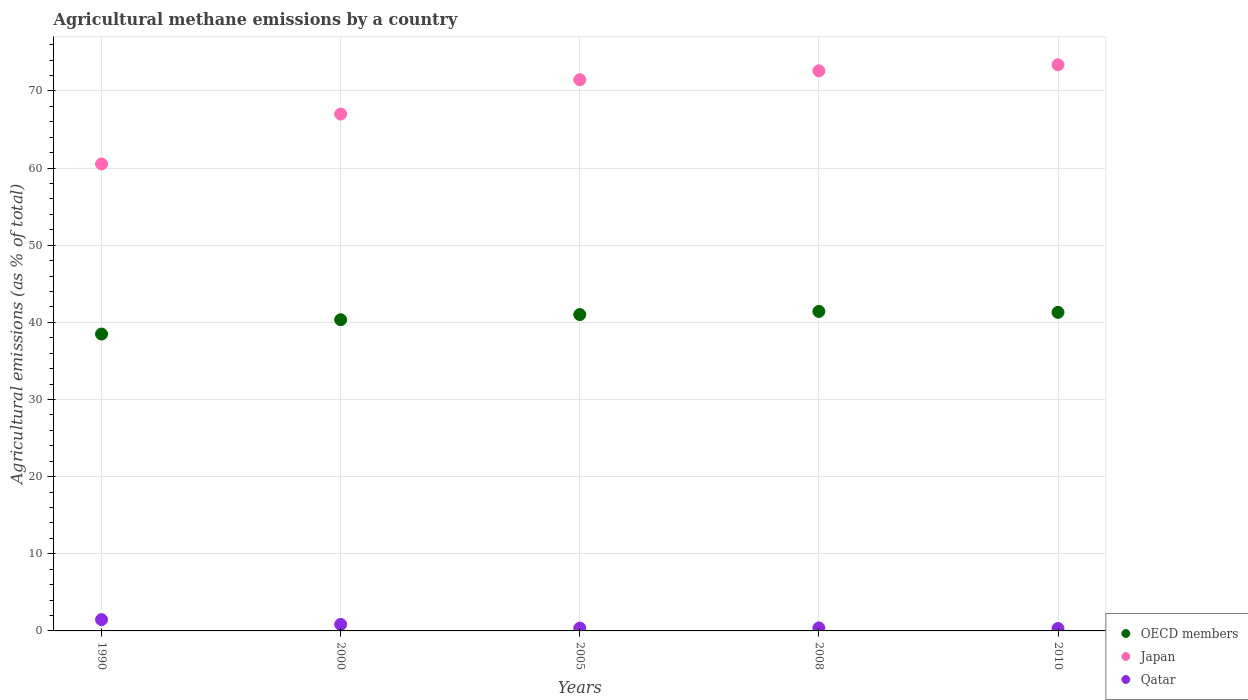What is the amount of agricultural methane emitted in Qatar in 2010?
Keep it short and to the point. 0.31. Across all years, what is the maximum amount of agricultural methane emitted in OECD members?
Offer a very short reply. 41.41. Across all years, what is the minimum amount of agricultural methane emitted in Qatar?
Give a very brief answer. 0.31. In which year was the amount of agricultural methane emitted in OECD members minimum?
Ensure brevity in your answer.  1990. What is the total amount of agricultural methane emitted in Qatar in the graph?
Your answer should be very brief. 3.38. What is the difference between the amount of agricultural methane emitted in OECD members in 2005 and that in 2008?
Make the answer very short. -0.41. What is the difference between the amount of agricultural methane emitted in Japan in 2000 and the amount of agricultural methane emitted in OECD members in 2005?
Give a very brief answer. 25.99. What is the average amount of agricultural methane emitted in Japan per year?
Offer a terse response. 68.99. In the year 2000, what is the difference between the amount of agricultural methane emitted in Qatar and amount of agricultural methane emitted in OECD members?
Your answer should be compact. -39.49. In how many years, is the amount of agricultural methane emitted in Japan greater than 60 %?
Ensure brevity in your answer.  5. What is the ratio of the amount of agricultural methane emitted in Japan in 1990 to that in 2005?
Offer a very short reply. 0.85. Is the amount of agricultural methane emitted in Japan in 1990 less than that in 2000?
Make the answer very short. Yes. What is the difference between the highest and the second highest amount of agricultural methane emitted in OECD members?
Offer a terse response. 0.12. What is the difference between the highest and the lowest amount of agricultural methane emitted in Qatar?
Ensure brevity in your answer.  1.15. In how many years, is the amount of agricultural methane emitted in Qatar greater than the average amount of agricultural methane emitted in Qatar taken over all years?
Offer a terse response. 2. Is the sum of the amount of agricultural methane emitted in OECD members in 2000 and 2005 greater than the maximum amount of agricultural methane emitted in Japan across all years?
Keep it short and to the point. Yes. Does the amount of agricultural methane emitted in Qatar monotonically increase over the years?
Your answer should be compact. No. Is the amount of agricultural methane emitted in Japan strictly greater than the amount of agricultural methane emitted in Qatar over the years?
Your answer should be very brief. Yes. How many years are there in the graph?
Give a very brief answer. 5. Does the graph contain any zero values?
Ensure brevity in your answer.  No. Does the graph contain grids?
Offer a terse response. Yes. What is the title of the graph?
Ensure brevity in your answer.  Agricultural methane emissions by a country. What is the label or title of the X-axis?
Your response must be concise. Years. What is the label or title of the Y-axis?
Offer a very short reply. Agricultural emissions (as % of total). What is the Agricultural emissions (as % of total) of OECD members in 1990?
Your response must be concise. 38.48. What is the Agricultural emissions (as % of total) of Japan in 1990?
Make the answer very short. 60.53. What is the Agricultural emissions (as % of total) in Qatar in 1990?
Your answer should be compact. 1.46. What is the Agricultural emissions (as % of total) in OECD members in 2000?
Provide a succinct answer. 40.33. What is the Agricultural emissions (as % of total) in Japan in 2000?
Your response must be concise. 66.99. What is the Agricultural emissions (as % of total) in Qatar in 2000?
Keep it short and to the point. 0.85. What is the Agricultural emissions (as % of total) in OECD members in 2005?
Provide a short and direct response. 41. What is the Agricultural emissions (as % of total) in Japan in 2005?
Offer a terse response. 71.44. What is the Agricultural emissions (as % of total) in Qatar in 2005?
Your answer should be compact. 0.36. What is the Agricultural emissions (as % of total) in OECD members in 2008?
Provide a succinct answer. 41.41. What is the Agricultural emissions (as % of total) in Japan in 2008?
Offer a terse response. 72.6. What is the Agricultural emissions (as % of total) in Qatar in 2008?
Provide a succinct answer. 0.39. What is the Agricultural emissions (as % of total) of OECD members in 2010?
Keep it short and to the point. 41.29. What is the Agricultural emissions (as % of total) in Japan in 2010?
Offer a terse response. 73.38. What is the Agricultural emissions (as % of total) of Qatar in 2010?
Your answer should be compact. 0.31. Across all years, what is the maximum Agricultural emissions (as % of total) in OECD members?
Your response must be concise. 41.41. Across all years, what is the maximum Agricultural emissions (as % of total) of Japan?
Keep it short and to the point. 73.38. Across all years, what is the maximum Agricultural emissions (as % of total) in Qatar?
Make the answer very short. 1.46. Across all years, what is the minimum Agricultural emissions (as % of total) in OECD members?
Keep it short and to the point. 38.48. Across all years, what is the minimum Agricultural emissions (as % of total) in Japan?
Provide a short and direct response. 60.53. Across all years, what is the minimum Agricultural emissions (as % of total) in Qatar?
Your answer should be compact. 0.31. What is the total Agricultural emissions (as % of total) in OECD members in the graph?
Make the answer very short. 202.52. What is the total Agricultural emissions (as % of total) in Japan in the graph?
Offer a terse response. 344.94. What is the total Agricultural emissions (as % of total) of Qatar in the graph?
Give a very brief answer. 3.38. What is the difference between the Agricultural emissions (as % of total) in OECD members in 1990 and that in 2000?
Provide a succinct answer. -1.86. What is the difference between the Agricultural emissions (as % of total) of Japan in 1990 and that in 2000?
Your response must be concise. -6.46. What is the difference between the Agricultural emissions (as % of total) in Qatar in 1990 and that in 2000?
Make the answer very short. 0.61. What is the difference between the Agricultural emissions (as % of total) of OECD members in 1990 and that in 2005?
Your answer should be very brief. -2.52. What is the difference between the Agricultural emissions (as % of total) in Japan in 1990 and that in 2005?
Keep it short and to the point. -10.92. What is the difference between the Agricultural emissions (as % of total) in Qatar in 1990 and that in 2005?
Your response must be concise. 1.1. What is the difference between the Agricultural emissions (as % of total) in OECD members in 1990 and that in 2008?
Your answer should be very brief. -2.93. What is the difference between the Agricultural emissions (as % of total) of Japan in 1990 and that in 2008?
Your answer should be very brief. -12.07. What is the difference between the Agricultural emissions (as % of total) in Qatar in 1990 and that in 2008?
Give a very brief answer. 1.07. What is the difference between the Agricultural emissions (as % of total) in OECD members in 1990 and that in 2010?
Ensure brevity in your answer.  -2.81. What is the difference between the Agricultural emissions (as % of total) in Japan in 1990 and that in 2010?
Offer a terse response. -12.86. What is the difference between the Agricultural emissions (as % of total) in Qatar in 1990 and that in 2010?
Your answer should be compact. 1.15. What is the difference between the Agricultural emissions (as % of total) of OECD members in 2000 and that in 2005?
Give a very brief answer. -0.67. What is the difference between the Agricultural emissions (as % of total) of Japan in 2000 and that in 2005?
Ensure brevity in your answer.  -4.46. What is the difference between the Agricultural emissions (as % of total) of Qatar in 2000 and that in 2005?
Make the answer very short. 0.49. What is the difference between the Agricultural emissions (as % of total) of OECD members in 2000 and that in 2008?
Make the answer very short. -1.08. What is the difference between the Agricultural emissions (as % of total) of Japan in 2000 and that in 2008?
Your answer should be very brief. -5.61. What is the difference between the Agricultural emissions (as % of total) in Qatar in 2000 and that in 2008?
Make the answer very short. 0.46. What is the difference between the Agricultural emissions (as % of total) in OECD members in 2000 and that in 2010?
Make the answer very short. -0.96. What is the difference between the Agricultural emissions (as % of total) of Japan in 2000 and that in 2010?
Your answer should be very brief. -6.39. What is the difference between the Agricultural emissions (as % of total) in Qatar in 2000 and that in 2010?
Keep it short and to the point. 0.54. What is the difference between the Agricultural emissions (as % of total) in OECD members in 2005 and that in 2008?
Your answer should be very brief. -0.41. What is the difference between the Agricultural emissions (as % of total) in Japan in 2005 and that in 2008?
Give a very brief answer. -1.15. What is the difference between the Agricultural emissions (as % of total) in Qatar in 2005 and that in 2008?
Offer a very short reply. -0.03. What is the difference between the Agricultural emissions (as % of total) of OECD members in 2005 and that in 2010?
Ensure brevity in your answer.  -0.29. What is the difference between the Agricultural emissions (as % of total) of Japan in 2005 and that in 2010?
Your response must be concise. -1.94. What is the difference between the Agricultural emissions (as % of total) of Qatar in 2005 and that in 2010?
Keep it short and to the point. 0.05. What is the difference between the Agricultural emissions (as % of total) of OECD members in 2008 and that in 2010?
Keep it short and to the point. 0.12. What is the difference between the Agricultural emissions (as % of total) in Japan in 2008 and that in 2010?
Offer a terse response. -0.79. What is the difference between the Agricultural emissions (as % of total) in Qatar in 2008 and that in 2010?
Your answer should be compact. 0.08. What is the difference between the Agricultural emissions (as % of total) in OECD members in 1990 and the Agricultural emissions (as % of total) in Japan in 2000?
Your answer should be very brief. -28.51. What is the difference between the Agricultural emissions (as % of total) in OECD members in 1990 and the Agricultural emissions (as % of total) in Qatar in 2000?
Ensure brevity in your answer.  37.63. What is the difference between the Agricultural emissions (as % of total) of Japan in 1990 and the Agricultural emissions (as % of total) of Qatar in 2000?
Offer a terse response. 59.68. What is the difference between the Agricultural emissions (as % of total) of OECD members in 1990 and the Agricultural emissions (as % of total) of Japan in 2005?
Give a very brief answer. -32.97. What is the difference between the Agricultural emissions (as % of total) of OECD members in 1990 and the Agricultural emissions (as % of total) of Qatar in 2005?
Provide a succinct answer. 38.12. What is the difference between the Agricultural emissions (as % of total) of Japan in 1990 and the Agricultural emissions (as % of total) of Qatar in 2005?
Provide a succinct answer. 60.16. What is the difference between the Agricultural emissions (as % of total) in OECD members in 1990 and the Agricultural emissions (as % of total) in Japan in 2008?
Your response must be concise. -34.12. What is the difference between the Agricultural emissions (as % of total) of OECD members in 1990 and the Agricultural emissions (as % of total) of Qatar in 2008?
Your answer should be very brief. 38.09. What is the difference between the Agricultural emissions (as % of total) in Japan in 1990 and the Agricultural emissions (as % of total) in Qatar in 2008?
Offer a terse response. 60.14. What is the difference between the Agricultural emissions (as % of total) of OECD members in 1990 and the Agricultural emissions (as % of total) of Japan in 2010?
Give a very brief answer. -34.9. What is the difference between the Agricultural emissions (as % of total) in OECD members in 1990 and the Agricultural emissions (as % of total) in Qatar in 2010?
Give a very brief answer. 38.17. What is the difference between the Agricultural emissions (as % of total) in Japan in 1990 and the Agricultural emissions (as % of total) in Qatar in 2010?
Keep it short and to the point. 60.22. What is the difference between the Agricultural emissions (as % of total) of OECD members in 2000 and the Agricultural emissions (as % of total) of Japan in 2005?
Provide a succinct answer. -31.11. What is the difference between the Agricultural emissions (as % of total) in OECD members in 2000 and the Agricultural emissions (as % of total) in Qatar in 2005?
Your answer should be compact. 39.97. What is the difference between the Agricultural emissions (as % of total) in Japan in 2000 and the Agricultural emissions (as % of total) in Qatar in 2005?
Offer a very short reply. 66.63. What is the difference between the Agricultural emissions (as % of total) in OECD members in 2000 and the Agricultural emissions (as % of total) in Japan in 2008?
Provide a short and direct response. -32.26. What is the difference between the Agricultural emissions (as % of total) of OECD members in 2000 and the Agricultural emissions (as % of total) of Qatar in 2008?
Your response must be concise. 39.95. What is the difference between the Agricultural emissions (as % of total) in Japan in 2000 and the Agricultural emissions (as % of total) in Qatar in 2008?
Offer a terse response. 66.6. What is the difference between the Agricultural emissions (as % of total) of OECD members in 2000 and the Agricultural emissions (as % of total) of Japan in 2010?
Ensure brevity in your answer.  -33.05. What is the difference between the Agricultural emissions (as % of total) in OECD members in 2000 and the Agricultural emissions (as % of total) in Qatar in 2010?
Provide a succinct answer. 40.02. What is the difference between the Agricultural emissions (as % of total) in Japan in 2000 and the Agricultural emissions (as % of total) in Qatar in 2010?
Give a very brief answer. 66.68. What is the difference between the Agricultural emissions (as % of total) in OECD members in 2005 and the Agricultural emissions (as % of total) in Japan in 2008?
Your response must be concise. -31.59. What is the difference between the Agricultural emissions (as % of total) of OECD members in 2005 and the Agricultural emissions (as % of total) of Qatar in 2008?
Make the answer very short. 40.61. What is the difference between the Agricultural emissions (as % of total) in Japan in 2005 and the Agricultural emissions (as % of total) in Qatar in 2008?
Provide a succinct answer. 71.05. What is the difference between the Agricultural emissions (as % of total) in OECD members in 2005 and the Agricultural emissions (as % of total) in Japan in 2010?
Provide a short and direct response. -32.38. What is the difference between the Agricultural emissions (as % of total) in OECD members in 2005 and the Agricultural emissions (as % of total) in Qatar in 2010?
Provide a short and direct response. 40.69. What is the difference between the Agricultural emissions (as % of total) of Japan in 2005 and the Agricultural emissions (as % of total) of Qatar in 2010?
Make the answer very short. 71.13. What is the difference between the Agricultural emissions (as % of total) of OECD members in 2008 and the Agricultural emissions (as % of total) of Japan in 2010?
Make the answer very short. -31.97. What is the difference between the Agricultural emissions (as % of total) of OECD members in 2008 and the Agricultural emissions (as % of total) of Qatar in 2010?
Offer a very short reply. 41.1. What is the difference between the Agricultural emissions (as % of total) of Japan in 2008 and the Agricultural emissions (as % of total) of Qatar in 2010?
Provide a succinct answer. 72.28. What is the average Agricultural emissions (as % of total) of OECD members per year?
Your answer should be very brief. 40.5. What is the average Agricultural emissions (as % of total) in Japan per year?
Make the answer very short. 68.99. What is the average Agricultural emissions (as % of total) in Qatar per year?
Your answer should be very brief. 0.68. In the year 1990, what is the difference between the Agricultural emissions (as % of total) in OECD members and Agricultural emissions (as % of total) in Japan?
Ensure brevity in your answer.  -22.05. In the year 1990, what is the difference between the Agricultural emissions (as % of total) of OECD members and Agricultural emissions (as % of total) of Qatar?
Offer a terse response. 37.02. In the year 1990, what is the difference between the Agricultural emissions (as % of total) of Japan and Agricultural emissions (as % of total) of Qatar?
Make the answer very short. 59.06. In the year 2000, what is the difference between the Agricultural emissions (as % of total) in OECD members and Agricultural emissions (as % of total) in Japan?
Offer a very short reply. -26.65. In the year 2000, what is the difference between the Agricultural emissions (as % of total) in OECD members and Agricultural emissions (as % of total) in Qatar?
Make the answer very short. 39.49. In the year 2000, what is the difference between the Agricultural emissions (as % of total) of Japan and Agricultural emissions (as % of total) of Qatar?
Keep it short and to the point. 66.14. In the year 2005, what is the difference between the Agricultural emissions (as % of total) of OECD members and Agricultural emissions (as % of total) of Japan?
Ensure brevity in your answer.  -30.44. In the year 2005, what is the difference between the Agricultural emissions (as % of total) in OECD members and Agricultural emissions (as % of total) in Qatar?
Give a very brief answer. 40.64. In the year 2005, what is the difference between the Agricultural emissions (as % of total) of Japan and Agricultural emissions (as % of total) of Qatar?
Provide a succinct answer. 71.08. In the year 2008, what is the difference between the Agricultural emissions (as % of total) of OECD members and Agricultural emissions (as % of total) of Japan?
Keep it short and to the point. -31.18. In the year 2008, what is the difference between the Agricultural emissions (as % of total) in OECD members and Agricultural emissions (as % of total) in Qatar?
Your answer should be compact. 41.02. In the year 2008, what is the difference between the Agricultural emissions (as % of total) of Japan and Agricultural emissions (as % of total) of Qatar?
Ensure brevity in your answer.  72.21. In the year 2010, what is the difference between the Agricultural emissions (as % of total) of OECD members and Agricultural emissions (as % of total) of Japan?
Give a very brief answer. -32.09. In the year 2010, what is the difference between the Agricultural emissions (as % of total) of OECD members and Agricultural emissions (as % of total) of Qatar?
Give a very brief answer. 40.98. In the year 2010, what is the difference between the Agricultural emissions (as % of total) of Japan and Agricultural emissions (as % of total) of Qatar?
Make the answer very short. 73.07. What is the ratio of the Agricultural emissions (as % of total) of OECD members in 1990 to that in 2000?
Your response must be concise. 0.95. What is the ratio of the Agricultural emissions (as % of total) in Japan in 1990 to that in 2000?
Keep it short and to the point. 0.9. What is the ratio of the Agricultural emissions (as % of total) of Qatar in 1990 to that in 2000?
Your response must be concise. 1.72. What is the ratio of the Agricultural emissions (as % of total) in OECD members in 1990 to that in 2005?
Give a very brief answer. 0.94. What is the ratio of the Agricultural emissions (as % of total) in Japan in 1990 to that in 2005?
Ensure brevity in your answer.  0.85. What is the ratio of the Agricultural emissions (as % of total) of Qatar in 1990 to that in 2005?
Give a very brief answer. 4.04. What is the ratio of the Agricultural emissions (as % of total) in OECD members in 1990 to that in 2008?
Your answer should be very brief. 0.93. What is the ratio of the Agricultural emissions (as % of total) of Japan in 1990 to that in 2008?
Give a very brief answer. 0.83. What is the ratio of the Agricultural emissions (as % of total) in Qatar in 1990 to that in 2008?
Provide a succinct answer. 3.76. What is the ratio of the Agricultural emissions (as % of total) of OECD members in 1990 to that in 2010?
Offer a very short reply. 0.93. What is the ratio of the Agricultural emissions (as % of total) in Japan in 1990 to that in 2010?
Your answer should be very brief. 0.82. What is the ratio of the Agricultural emissions (as % of total) of Qatar in 1990 to that in 2010?
Your answer should be very brief. 4.69. What is the ratio of the Agricultural emissions (as % of total) of OECD members in 2000 to that in 2005?
Ensure brevity in your answer.  0.98. What is the ratio of the Agricultural emissions (as % of total) in Japan in 2000 to that in 2005?
Keep it short and to the point. 0.94. What is the ratio of the Agricultural emissions (as % of total) of Qatar in 2000 to that in 2005?
Offer a terse response. 2.34. What is the ratio of the Agricultural emissions (as % of total) of Japan in 2000 to that in 2008?
Give a very brief answer. 0.92. What is the ratio of the Agricultural emissions (as % of total) in Qatar in 2000 to that in 2008?
Keep it short and to the point. 2.18. What is the ratio of the Agricultural emissions (as % of total) in OECD members in 2000 to that in 2010?
Keep it short and to the point. 0.98. What is the ratio of the Agricultural emissions (as % of total) of Japan in 2000 to that in 2010?
Your response must be concise. 0.91. What is the ratio of the Agricultural emissions (as % of total) in Qatar in 2000 to that in 2010?
Offer a terse response. 2.72. What is the ratio of the Agricultural emissions (as % of total) in Japan in 2005 to that in 2008?
Your answer should be very brief. 0.98. What is the ratio of the Agricultural emissions (as % of total) in Qatar in 2005 to that in 2008?
Make the answer very short. 0.93. What is the ratio of the Agricultural emissions (as % of total) of Japan in 2005 to that in 2010?
Provide a succinct answer. 0.97. What is the ratio of the Agricultural emissions (as % of total) of Qatar in 2005 to that in 2010?
Keep it short and to the point. 1.16. What is the ratio of the Agricultural emissions (as % of total) in Japan in 2008 to that in 2010?
Give a very brief answer. 0.99. What is the ratio of the Agricultural emissions (as % of total) in Qatar in 2008 to that in 2010?
Give a very brief answer. 1.25. What is the difference between the highest and the second highest Agricultural emissions (as % of total) in OECD members?
Provide a short and direct response. 0.12. What is the difference between the highest and the second highest Agricultural emissions (as % of total) in Japan?
Give a very brief answer. 0.79. What is the difference between the highest and the second highest Agricultural emissions (as % of total) of Qatar?
Ensure brevity in your answer.  0.61. What is the difference between the highest and the lowest Agricultural emissions (as % of total) of OECD members?
Your answer should be very brief. 2.93. What is the difference between the highest and the lowest Agricultural emissions (as % of total) of Japan?
Your response must be concise. 12.86. What is the difference between the highest and the lowest Agricultural emissions (as % of total) of Qatar?
Provide a short and direct response. 1.15. 